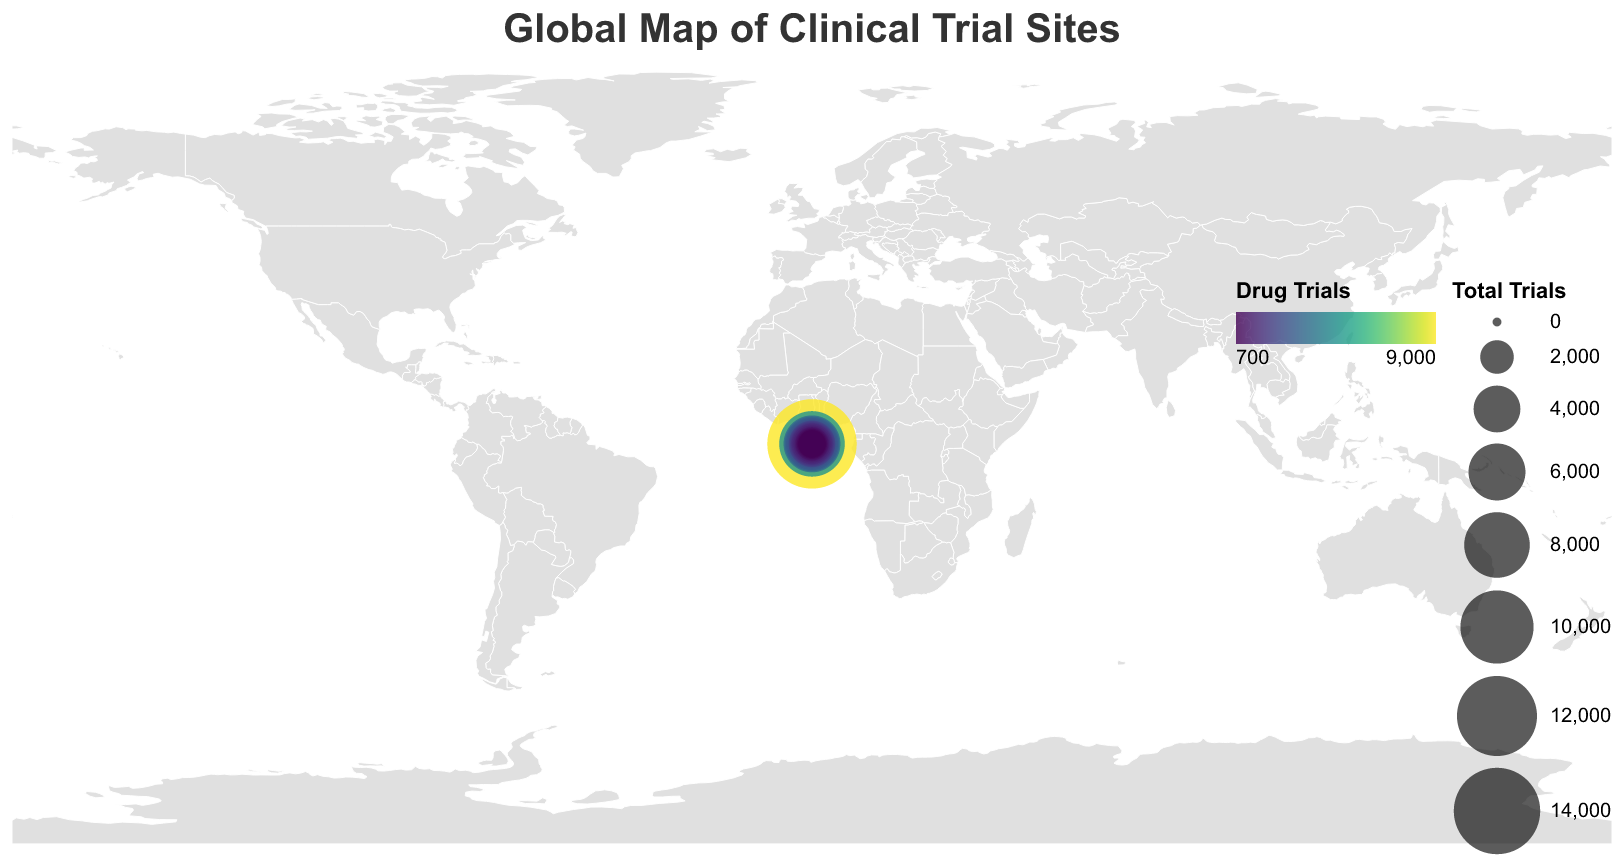What is the title of the figure? The title is typically located at the top of the figure. It is written in a large, clear font. Here, it reads "Global Map of Clinical Trial Sites".
Answer: Global Map of Clinical Trial Sites Which country has the highest number of total clinical trials? By looking at the sizes of the circles, the largest circle corresponds to the United States, indicating it has the highest number of total clinical trials.
Answer: United States How many drug trials are ongoing in Germany? By hovering over the circle located in Germany, the tooltip shows the number of drug trials as 3,500.
Answer: 3,500 Which countries have fewer than 2,000 total clinical trials? Scan the map for smaller circles and hover to check the tooltip. Countries with fewer than 2,000 trials include Russia, Switzerland, Belgium, Sweden, Poland, and Denmark.
Answer: Russia, Switzerland, Belgium, Sweden, Poland, Denmark What is the sum of drug and device trials in Japan? The tooltip for Japan shows 3,000 drug trials and 1,500 device trials. Summing these gives us 3,000 + 1,500 = 4,500.
Answer: 4,500 Compare the number of procedure trials between Brazil and South Korea. Which country has more? By checking the tooltips for both countries, Brazil has 500 procedure trials and South Korea has 400 procedure trials. Therefore, Brazil has more.
Answer: Brazil Which country has the smallest number of total clinical trials and how many? Looking at the smallest circles and referring to the tooltips, Denmark has the smallest number of total clinical trials, which is 1,300.
Answer: Denmark, 1,300 What color scale is used to represent drug trials on the map? The figure legend indicates that the color scale for drug trials follows a specific scheme, identified as "viridis".
Answer: viridis List the number of device trials in countries from Australia to Belgium. Using the tooltips, we find the number of device trials for each: Australia (900), Brazil (800), South Korea (800), India (700), Netherlands (600), Russia (600), Switzerland (500), Belgium (500).
Answer: Australia (900), Brazil (800), South Korea (800), India (700), Netherlands (600), Russia (600), Switzerland (500), Belgium (500) What can we infer about the geographic spread of clinical trials from this map? The large circles in North America and Europe, and some in Asia, indicate these regions have high numbers of clinical trials. Areas like Africa and South America have fewer and smaller circles, showing fewer clinical trials.
Answer: High activity in North America, Europe, and parts of Asia; less in Africa and South America 